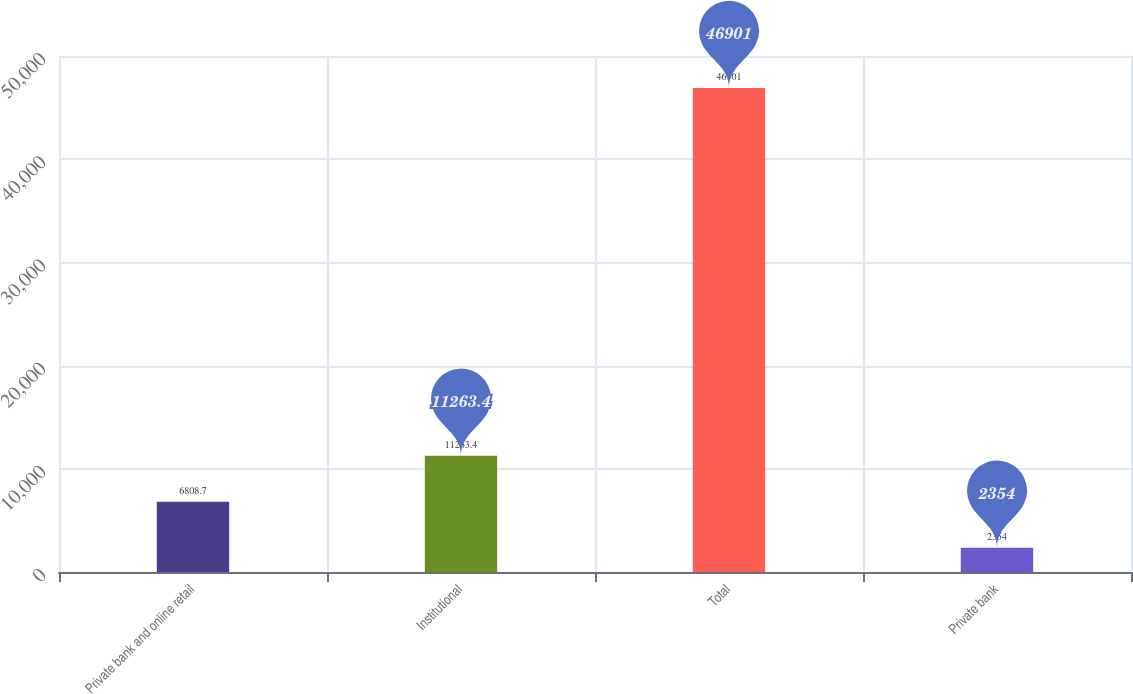Convert chart. <chart><loc_0><loc_0><loc_500><loc_500><bar_chart><fcel>Private bank and online retail<fcel>Institutional<fcel>Total<fcel>Private bank<nl><fcel>6808.7<fcel>11263.4<fcel>46901<fcel>2354<nl></chart> 